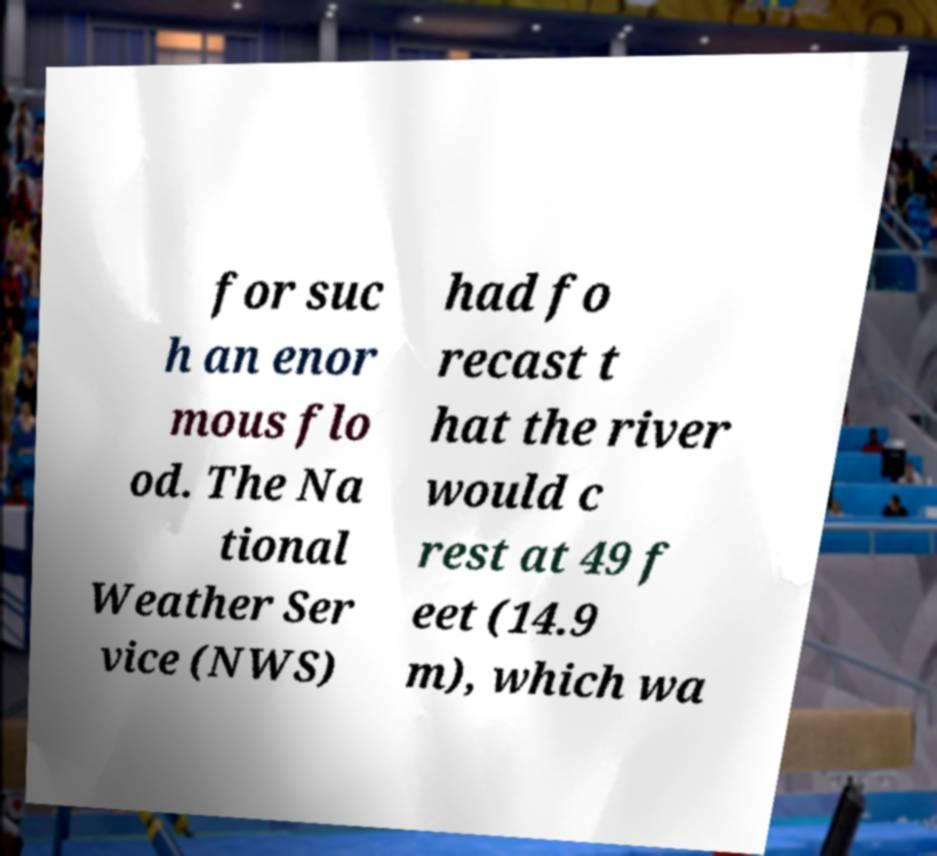Can you accurately transcribe the text from the provided image for me? for suc h an enor mous flo od. The Na tional Weather Ser vice (NWS) had fo recast t hat the river would c rest at 49 f eet (14.9 m), which wa 